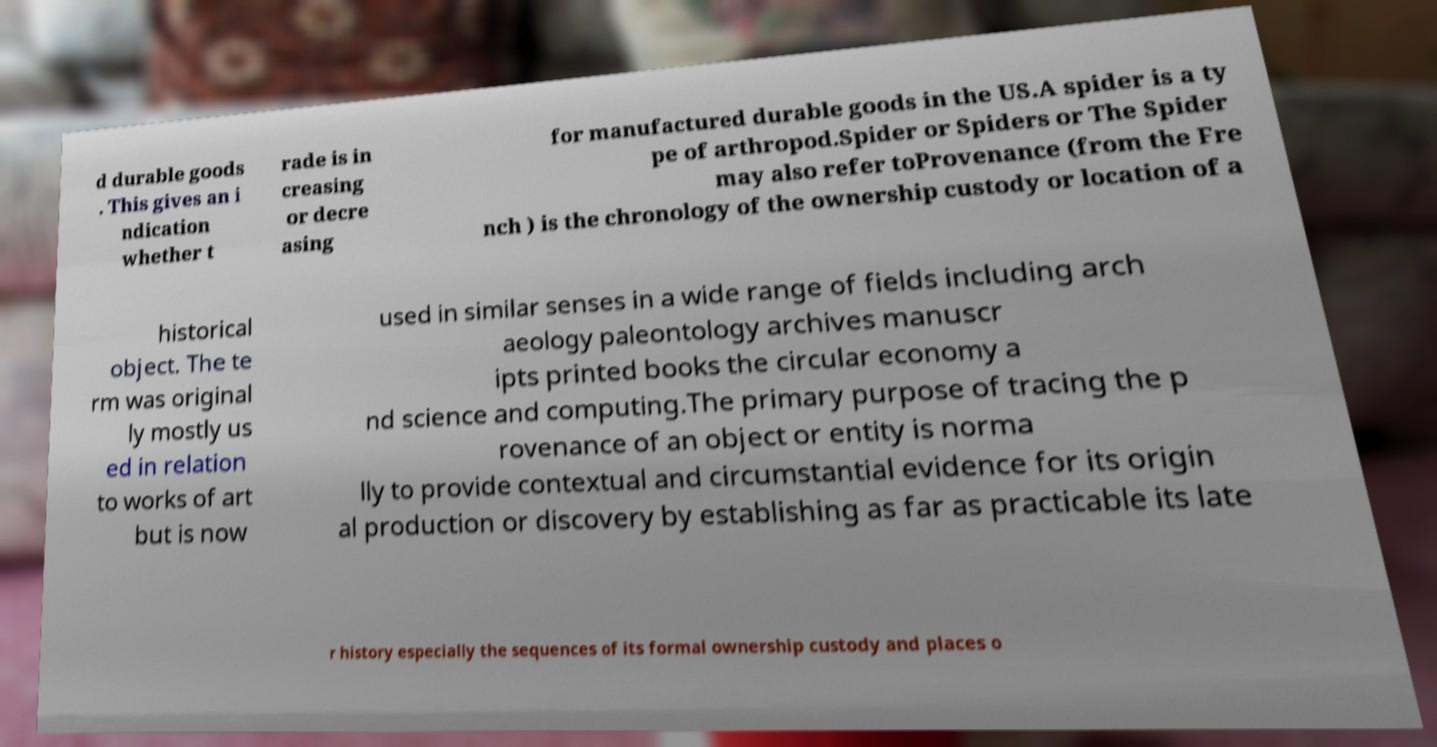Please read and relay the text visible in this image. What does it say? d durable goods . This gives an i ndication whether t rade is in creasing or decre asing for manufactured durable goods in the US.A spider is a ty pe of arthropod.Spider or Spiders or The Spider may also refer toProvenance (from the Fre nch ) is the chronology of the ownership custody or location of a historical object. The te rm was original ly mostly us ed in relation to works of art but is now used in similar senses in a wide range of fields including arch aeology paleontology archives manuscr ipts printed books the circular economy a nd science and computing.The primary purpose of tracing the p rovenance of an object or entity is norma lly to provide contextual and circumstantial evidence for its origin al production or discovery by establishing as far as practicable its late r history especially the sequences of its formal ownership custody and places o 